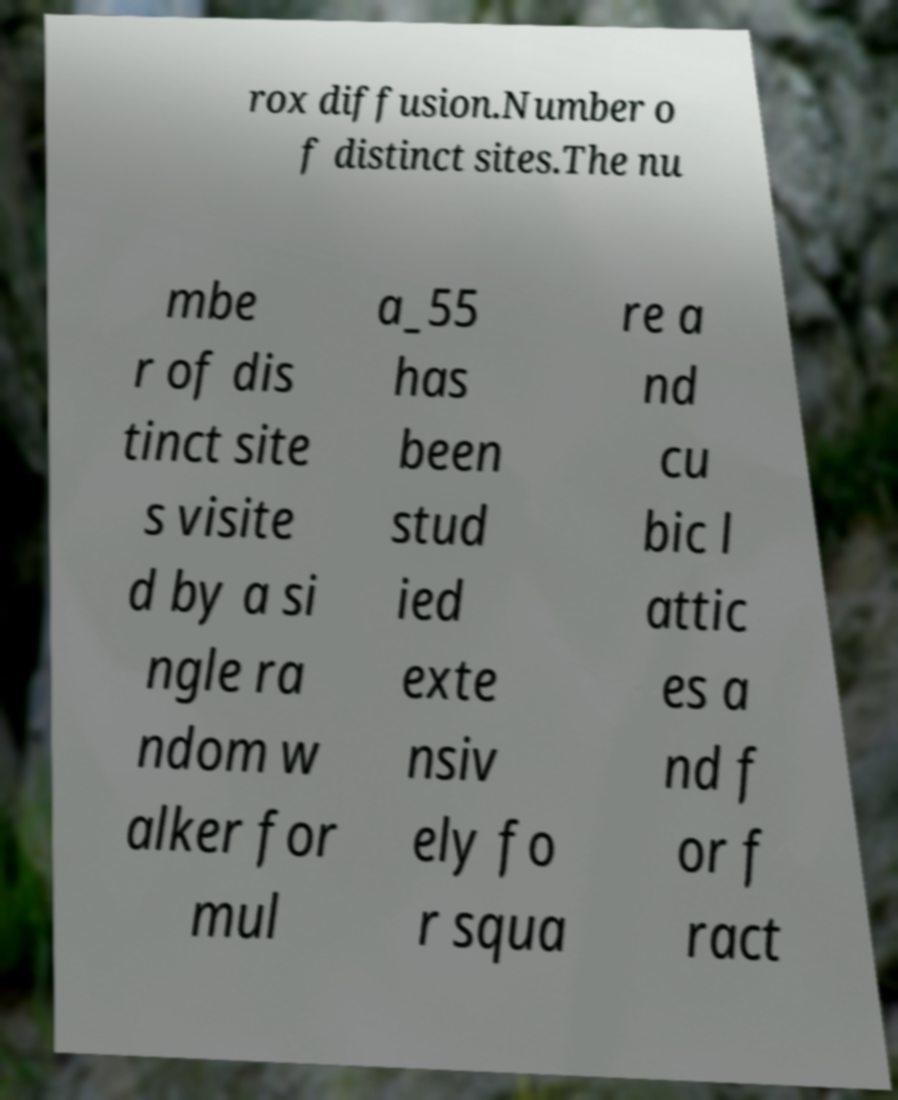I need the written content from this picture converted into text. Can you do that? rox diffusion.Number o f distinct sites.The nu mbe r of dis tinct site s visite d by a si ngle ra ndom w alker for mul a_55 has been stud ied exte nsiv ely fo r squa re a nd cu bic l attic es a nd f or f ract 